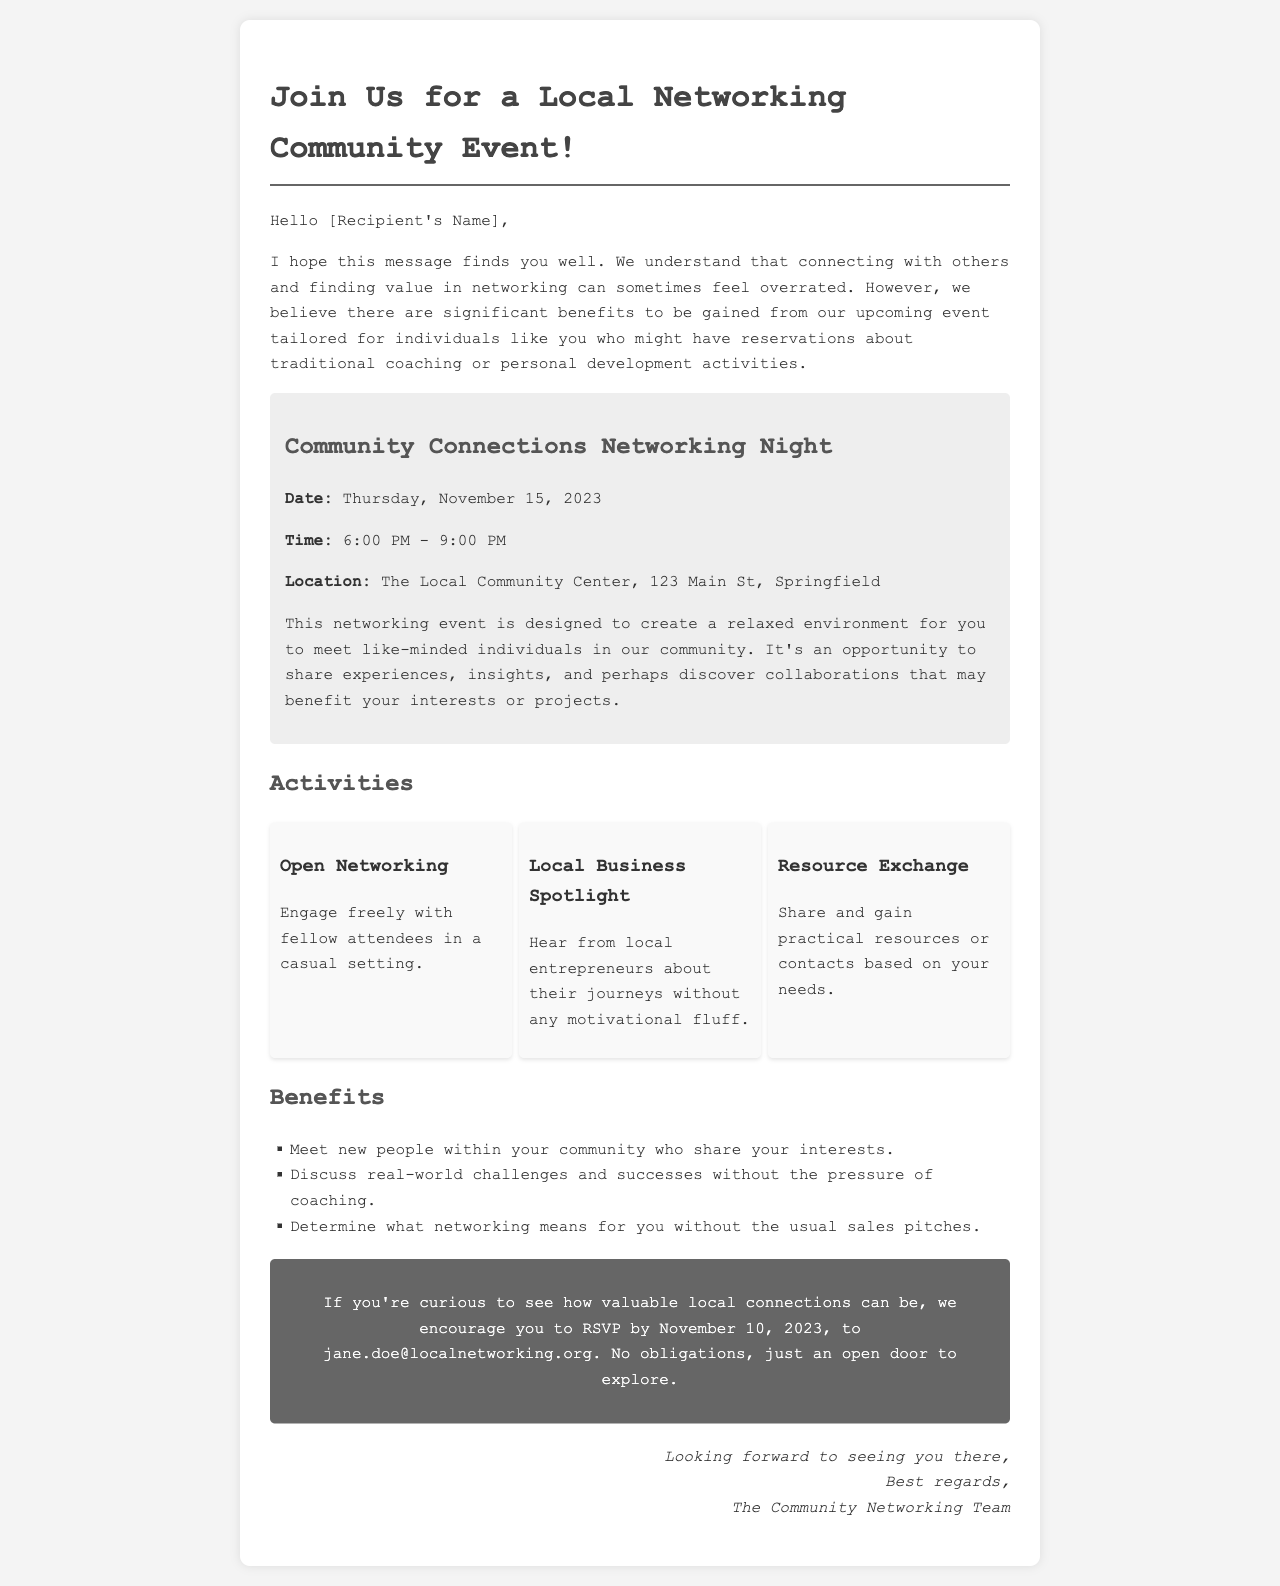What is the date of the event? The date of the event is clearly stated in the document as Thursday, November 15, 2023.
Answer: Thursday, November 15, 2023 What are the event times? The event times are listed in the document as 6:00 PM - 9:00 PM.
Answer: 6:00 PM - 9:00 PM Where is the networking event being held? The location of the event is mentioned as The Local Community Center, 123 Main St, Springfield.
Answer: The Local Community Center, 123 Main St, Springfield What is one of the activities mentioned? The document lists several activities, one of them being Open Networking.
Answer: Open Networking What is a benefit of attending the event? The document states that a benefit is to meet new people within your community who share your interests.
Answer: Meet new people within your community who share your interests Why might someone skeptical of networking appreciate this event? The document implies that the event is designed to create a relaxed environment with no sales pitches, allowing for genuine connections.
Answer: No sales pitches What should attendees do if they want to RSVP? The document instructs attendees to RSVP by sending an email to jane.doe@localnetworking.org.
Answer: Email jane.doe@localnetworking.org What is the deadline to RSVP? The RSVP deadline is specified in the document as November 10, 2023.
Answer: November 10, 2023 What type of email is this document? The document is an invitation email promoting a community event.
Answer: Invitation email 